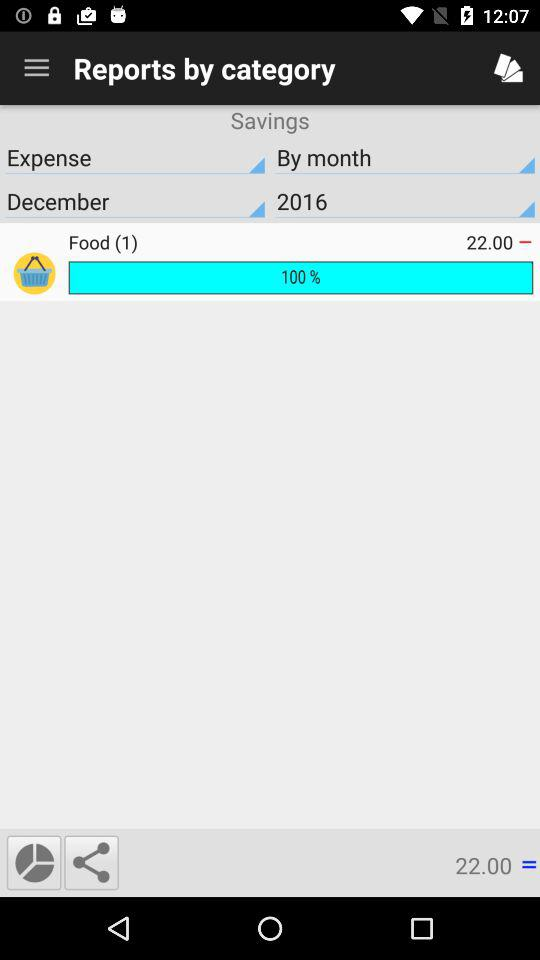Which month is selected? The selected month is December. 